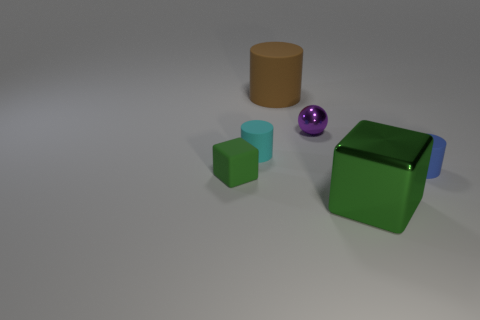What is the material of the blue object that is the same shape as the brown thing?
Your answer should be very brief. Rubber. There is a matte cube; does it have the same color as the big object that is to the right of the tiny purple sphere?
Provide a short and direct response. Yes. How many cylinders are green metallic things or tiny purple things?
Give a very brief answer. 0. What is the color of the small cylinder that is behind the tiny blue thing?
Your answer should be very brief. Cyan. The matte thing that is the same color as the big block is what shape?
Offer a very short reply. Cube. What number of blocks are the same size as the cyan matte thing?
Your answer should be compact. 1. There is a tiny matte thing to the right of the purple shiny ball; is its shape the same as the large object that is to the right of the purple shiny object?
Provide a short and direct response. No. What is the material of the cube that is in front of the tiny object in front of the small matte object on the right side of the large brown thing?
Offer a terse response. Metal. There is a object that is the same size as the green shiny cube; what shape is it?
Offer a very short reply. Cylinder. Is there a metal block that has the same color as the small matte block?
Give a very brief answer. Yes. 